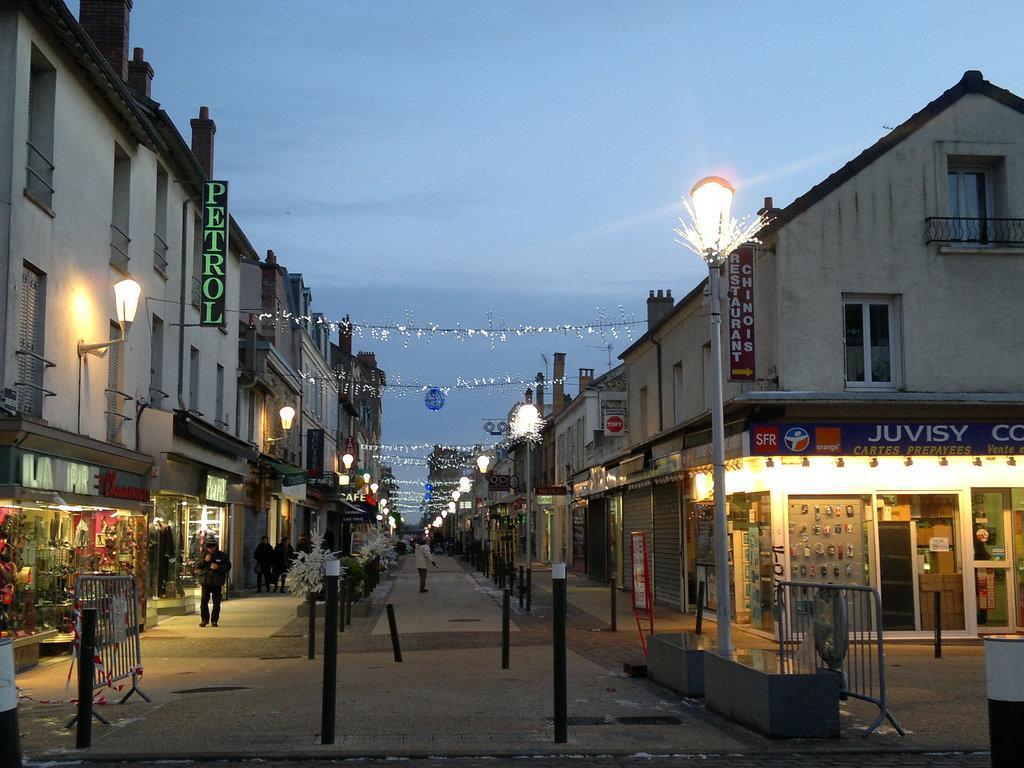How would you summarize this image in a sentence or two? This is a street view in this image I can see decorative pole lights throughout the street and shops on both sides of the street, some people are standing and walking, at the top of the image I can see the sky. 